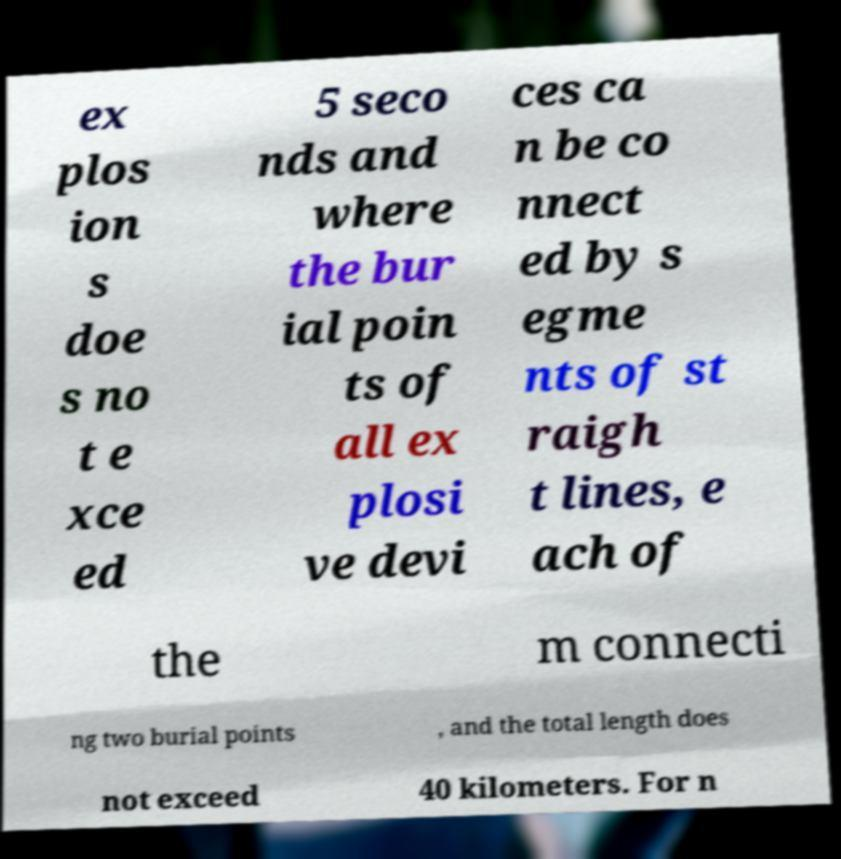Could you assist in decoding the text presented in this image and type it out clearly? ex plos ion s doe s no t e xce ed 5 seco nds and where the bur ial poin ts of all ex plosi ve devi ces ca n be co nnect ed by s egme nts of st raigh t lines, e ach of the m connecti ng two burial points , and the total length does not exceed 40 kilometers. For n 